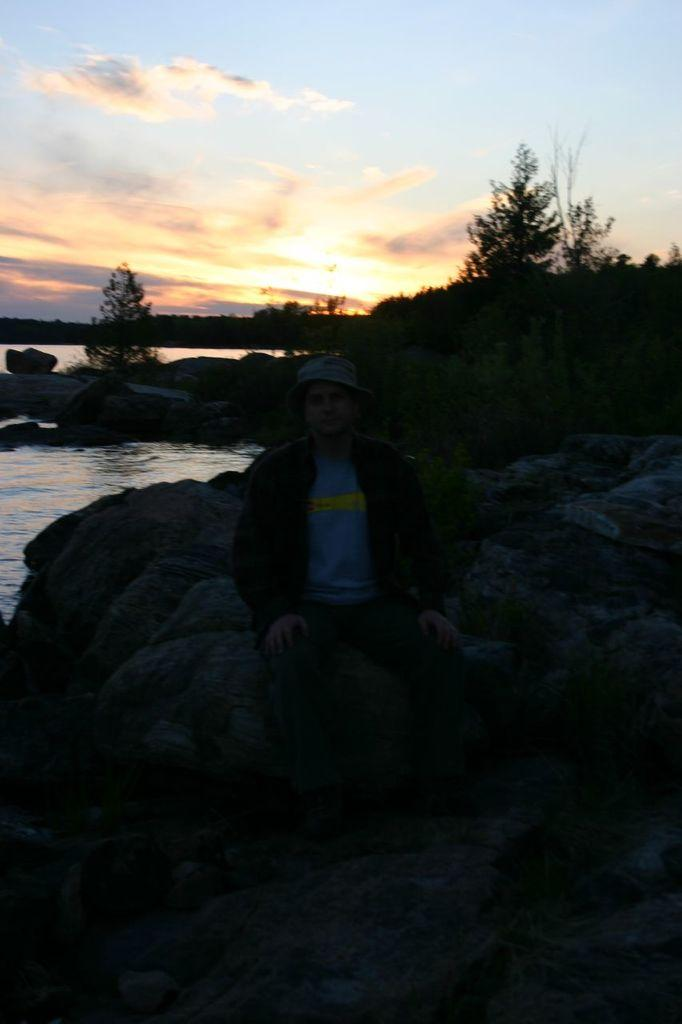What is the person in the image doing? There is a person sitting on a rock in the image. What can be seen in the background of the image? There are trees in the background of the image. How would you describe the sky in the image? The sky is cloudy in the image. What type of bells can be heard ringing in the image? There are no bells present in the image, so it is not possible to hear them ringing. 